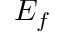<formula> <loc_0><loc_0><loc_500><loc_500>E _ { f }</formula> 